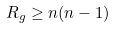<formula> <loc_0><loc_0><loc_500><loc_500>R _ { g } \geq n ( n - 1 )</formula> 